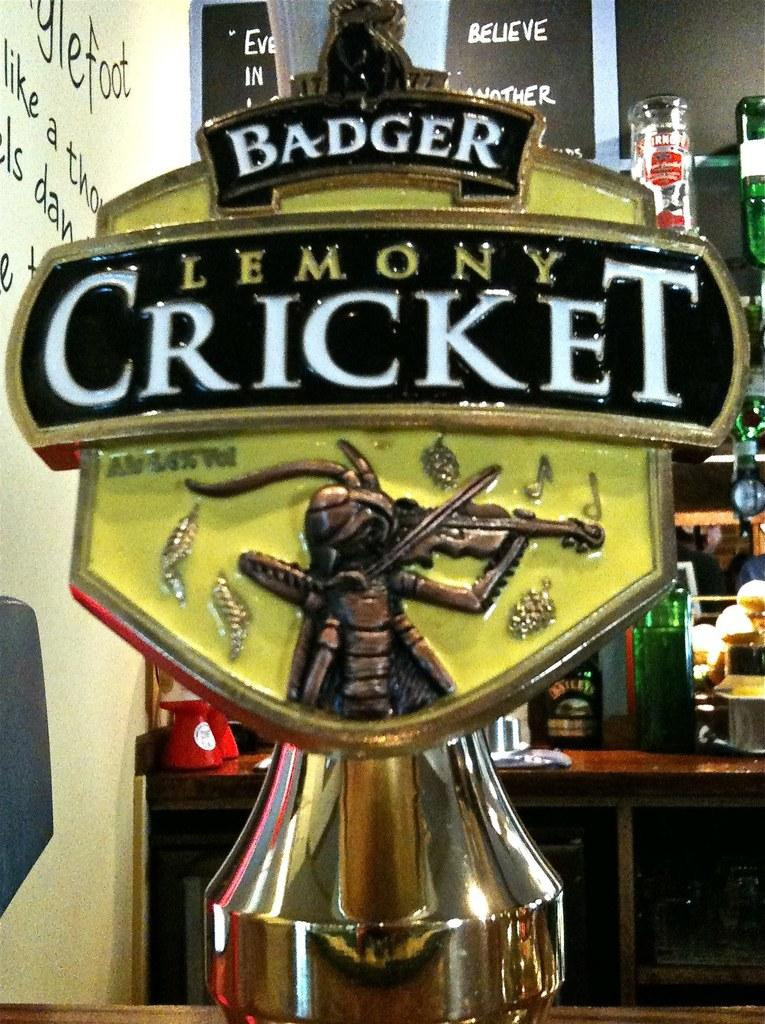Provide a one-sentence caption for the provided image. A beer tap for Badger Lemoney Cricket has a fiddling cricket on it. 